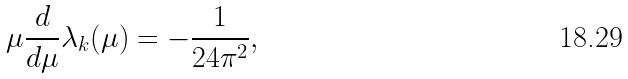<formula> <loc_0><loc_0><loc_500><loc_500>\mu { \frac { d } { d \mu } } \lambda _ { k } ( \mu ) = - { \frac { 1 } { 2 4 \pi ^ { 2 } } } ,</formula> 